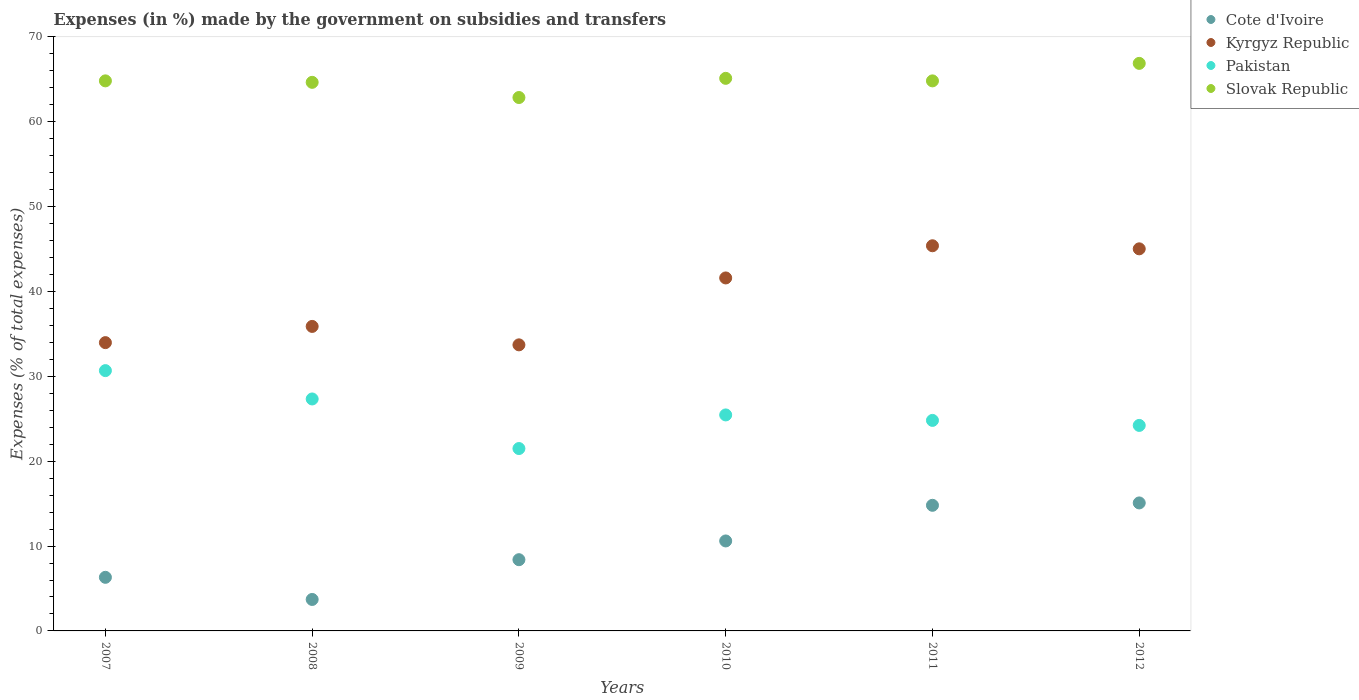Is the number of dotlines equal to the number of legend labels?
Keep it short and to the point. Yes. What is the percentage of expenses made by the government on subsidies and transfers in Cote d'Ivoire in 2008?
Provide a short and direct response. 3.71. Across all years, what is the maximum percentage of expenses made by the government on subsidies and transfers in Cote d'Ivoire?
Make the answer very short. 15.08. Across all years, what is the minimum percentage of expenses made by the government on subsidies and transfers in Pakistan?
Give a very brief answer. 21.49. In which year was the percentage of expenses made by the government on subsidies and transfers in Cote d'Ivoire minimum?
Your answer should be very brief. 2008. What is the total percentage of expenses made by the government on subsidies and transfers in Slovak Republic in the graph?
Make the answer very short. 389.15. What is the difference between the percentage of expenses made by the government on subsidies and transfers in Pakistan in 2009 and that in 2012?
Your answer should be very brief. -2.72. What is the difference between the percentage of expenses made by the government on subsidies and transfers in Slovak Republic in 2011 and the percentage of expenses made by the government on subsidies and transfers in Pakistan in 2009?
Keep it short and to the point. 43.33. What is the average percentage of expenses made by the government on subsidies and transfers in Cote d'Ivoire per year?
Offer a terse response. 9.82. In the year 2008, what is the difference between the percentage of expenses made by the government on subsidies and transfers in Cote d'Ivoire and percentage of expenses made by the government on subsidies and transfers in Slovak Republic?
Ensure brevity in your answer.  -60.94. What is the ratio of the percentage of expenses made by the government on subsidies and transfers in Slovak Republic in 2011 to that in 2012?
Keep it short and to the point. 0.97. Is the percentage of expenses made by the government on subsidies and transfers in Slovak Republic in 2007 less than that in 2009?
Your answer should be compact. No. What is the difference between the highest and the second highest percentage of expenses made by the government on subsidies and transfers in Kyrgyz Republic?
Give a very brief answer. 0.36. What is the difference between the highest and the lowest percentage of expenses made by the government on subsidies and transfers in Kyrgyz Republic?
Your answer should be very brief. 11.68. In how many years, is the percentage of expenses made by the government on subsidies and transfers in Kyrgyz Republic greater than the average percentage of expenses made by the government on subsidies and transfers in Kyrgyz Republic taken over all years?
Your response must be concise. 3. Is the percentage of expenses made by the government on subsidies and transfers in Cote d'Ivoire strictly greater than the percentage of expenses made by the government on subsidies and transfers in Kyrgyz Republic over the years?
Offer a terse response. No. Is the percentage of expenses made by the government on subsidies and transfers in Pakistan strictly less than the percentage of expenses made by the government on subsidies and transfers in Cote d'Ivoire over the years?
Ensure brevity in your answer.  No. How many dotlines are there?
Provide a short and direct response. 4. What is the difference between two consecutive major ticks on the Y-axis?
Offer a very short reply. 10. How many legend labels are there?
Provide a short and direct response. 4. What is the title of the graph?
Offer a very short reply. Expenses (in %) made by the government on subsidies and transfers. What is the label or title of the Y-axis?
Your answer should be very brief. Expenses (% of total expenses). What is the Expenses (% of total expenses) in Cote d'Ivoire in 2007?
Offer a terse response. 6.32. What is the Expenses (% of total expenses) in Kyrgyz Republic in 2007?
Provide a succinct answer. 33.97. What is the Expenses (% of total expenses) of Pakistan in 2007?
Provide a short and direct response. 30.67. What is the Expenses (% of total expenses) of Slovak Republic in 2007?
Offer a very short reply. 64.82. What is the Expenses (% of total expenses) in Cote d'Ivoire in 2008?
Ensure brevity in your answer.  3.71. What is the Expenses (% of total expenses) of Kyrgyz Republic in 2008?
Your response must be concise. 35.88. What is the Expenses (% of total expenses) in Pakistan in 2008?
Make the answer very short. 27.33. What is the Expenses (% of total expenses) in Slovak Republic in 2008?
Your answer should be very brief. 64.65. What is the Expenses (% of total expenses) of Cote d'Ivoire in 2009?
Offer a very short reply. 8.39. What is the Expenses (% of total expenses) in Kyrgyz Republic in 2009?
Keep it short and to the point. 33.71. What is the Expenses (% of total expenses) of Pakistan in 2009?
Give a very brief answer. 21.49. What is the Expenses (% of total expenses) of Slovak Republic in 2009?
Provide a short and direct response. 62.86. What is the Expenses (% of total expenses) of Cote d'Ivoire in 2010?
Keep it short and to the point. 10.6. What is the Expenses (% of total expenses) in Kyrgyz Republic in 2010?
Give a very brief answer. 41.6. What is the Expenses (% of total expenses) of Pakistan in 2010?
Offer a very short reply. 25.45. What is the Expenses (% of total expenses) of Slovak Republic in 2010?
Provide a succinct answer. 65.12. What is the Expenses (% of total expenses) of Cote d'Ivoire in 2011?
Ensure brevity in your answer.  14.8. What is the Expenses (% of total expenses) of Kyrgyz Republic in 2011?
Your response must be concise. 45.39. What is the Expenses (% of total expenses) of Pakistan in 2011?
Make the answer very short. 24.81. What is the Expenses (% of total expenses) in Slovak Republic in 2011?
Ensure brevity in your answer.  64.82. What is the Expenses (% of total expenses) of Cote d'Ivoire in 2012?
Make the answer very short. 15.08. What is the Expenses (% of total expenses) in Kyrgyz Republic in 2012?
Offer a very short reply. 45.03. What is the Expenses (% of total expenses) of Pakistan in 2012?
Your answer should be very brief. 24.22. What is the Expenses (% of total expenses) in Slovak Republic in 2012?
Ensure brevity in your answer.  66.88. Across all years, what is the maximum Expenses (% of total expenses) of Cote d'Ivoire?
Your answer should be compact. 15.08. Across all years, what is the maximum Expenses (% of total expenses) in Kyrgyz Republic?
Make the answer very short. 45.39. Across all years, what is the maximum Expenses (% of total expenses) in Pakistan?
Your response must be concise. 30.67. Across all years, what is the maximum Expenses (% of total expenses) in Slovak Republic?
Provide a short and direct response. 66.88. Across all years, what is the minimum Expenses (% of total expenses) in Cote d'Ivoire?
Offer a very short reply. 3.71. Across all years, what is the minimum Expenses (% of total expenses) of Kyrgyz Republic?
Give a very brief answer. 33.71. Across all years, what is the minimum Expenses (% of total expenses) of Pakistan?
Give a very brief answer. 21.49. Across all years, what is the minimum Expenses (% of total expenses) of Slovak Republic?
Offer a very short reply. 62.86. What is the total Expenses (% of total expenses) of Cote d'Ivoire in the graph?
Give a very brief answer. 58.91. What is the total Expenses (% of total expenses) of Kyrgyz Republic in the graph?
Your response must be concise. 235.58. What is the total Expenses (% of total expenses) in Pakistan in the graph?
Offer a very short reply. 153.98. What is the total Expenses (% of total expenses) of Slovak Republic in the graph?
Your response must be concise. 389.15. What is the difference between the Expenses (% of total expenses) in Cote d'Ivoire in 2007 and that in 2008?
Your response must be concise. 2.61. What is the difference between the Expenses (% of total expenses) in Kyrgyz Republic in 2007 and that in 2008?
Your response must be concise. -1.91. What is the difference between the Expenses (% of total expenses) in Pakistan in 2007 and that in 2008?
Your response must be concise. 3.34. What is the difference between the Expenses (% of total expenses) in Slovak Republic in 2007 and that in 2008?
Make the answer very short. 0.17. What is the difference between the Expenses (% of total expenses) of Cote d'Ivoire in 2007 and that in 2009?
Your response must be concise. -2.08. What is the difference between the Expenses (% of total expenses) in Kyrgyz Republic in 2007 and that in 2009?
Your answer should be compact. 0.26. What is the difference between the Expenses (% of total expenses) in Pakistan in 2007 and that in 2009?
Ensure brevity in your answer.  9.18. What is the difference between the Expenses (% of total expenses) of Slovak Republic in 2007 and that in 2009?
Your answer should be very brief. 1.96. What is the difference between the Expenses (% of total expenses) in Cote d'Ivoire in 2007 and that in 2010?
Your answer should be very brief. -4.29. What is the difference between the Expenses (% of total expenses) of Kyrgyz Republic in 2007 and that in 2010?
Make the answer very short. -7.62. What is the difference between the Expenses (% of total expenses) in Pakistan in 2007 and that in 2010?
Give a very brief answer. 5.22. What is the difference between the Expenses (% of total expenses) in Slovak Republic in 2007 and that in 2010?
Offer a terse response. -0.3. What is the difference between the Expenses (% of total expenses) in Cote d'Ivoire in 2007 and that in 2011?
Give a very brief answer. -8.49. What is the difference between the Expenses (% of total expenses) of Kyrgyz Republic in 2007 and that in 2011?
Your answer should be very brief. -11.41. What is the difference between the Expenses (% of total expenses) of Pakistan in 2007 and that in 2011?
Give a very brief answer. 5.87. What is the difference between the Expenses (% of total expenses) in Slovak Republic in 2007 and that in 2011?
Your answer should be compact. 0. What is the difference between the Expenses (% of total expenses) of Cote d'Ivoire in 2007 and that in 2012?
Make the answer very short. -8.77. What is the difference between the Expenses (% of total expenses) of Kyrgyz Republic in 2007 and that in 2012?
Offer a very short reply. -11.05. What is the difference between the Expenses (% of total expenses) in Pakistan in 2007 and that in 2012?
Offer a terse response. 6.46. What is the difference between the Expenses (% of total expenses) of Slovak Republic in 2007 and that in 2012?
Offer a very short reply. -2.06. What is the difference between the Expenses (% of total expenses) in Cote d'Ivoire in 2008 and that in 2009?
Ensure brevity in your answer.  -4.69. What is the difference between the Expenses (% of total expenses) in Kyrgyz Republic in 2008 and that in 2009?
Keep it short and to the point. 2.17. What is the difference between the Expenses (% of total expenses) of Pakistan in 2008 and that in 2009?
Keep it short and to the point. 5.84. What is the difference between the Expenses (% of total expenses) of Slovak Republic in 2008 and that in 2009?
Your answer should be very brief. 1.79. What is the difference between the Expenses (% of total expenses) in Cote d'Ivoire in 2008 and that in 2010?
Your response must be concise. -6.89. What is the difference between the Expenses (% of total expenses) in Kyrgyz Republic in 2008 and that in 2010?
Ensure brevity in your answer.  -5.71. What is the difference between the Expenses (% of total expenses) in Pakistan in 2008 and that in 2010?
Provide a succinct answer. 1.88. What is the difference between the Expenses (% of total expenses) of Slovak Republic in 2008 and that in 2010?
Your answer should be very brief. -0.47. What is the difference between the Expenses (% of total expenses) in Cote d'Ivoire in 2008 and that in 2011?
Make the answer very short. -11.1. What is the difference between the Expenses (% of total expenses) in Kyrgyz Republic in 2008 and that in 2011?
Your answer should be compact. -9.5. What is the difference between the Expenses (% of total expenses) of Pakistan in 2008 and that in 2011?
Your answer should be compact. 2.53. What is the difference between the Expenses (% of total expenses) in Slovak Republic in 2008 and that in 2011?
Your answer should be very brief. -0.17. What is the difference between the Expenses (% of total expenses) of Cote d'Ivoire in 2008 and that in 2012?
Provide a short and direct response. -11.38. What is the difference between the Expenses (% of total expenses) of Kyrgyz Republic in 2008 and that in 2012?
Provide a succinct answer. -9.14. What is the difference between the Expenses (% of total expenses) in Pakistan in 2008 and that in 2012?
Provide a short and direct response. 3.12. What is the difference between the Expenses (% of total expenses) of Slovak Republic in 2008 and that in 2012?
Offer a very short reply. -2.23. What is the difference between the Expenses (% of total expenses) in Cote d'Ivoire in 2009 and that in 2010?
Ensure brevity in your answer.  -2.21. What is the difference between the Expenses (% of total expenses) in Kyrgyz Republic in 2009 and that in 2010?
Provide a succinct answer. -7.88. What is the difference between the Expenses (% of total expenses) in Pakistan in 2009 and that in 2010?
Provide a succinct answer. -3.96. What is the difference between the Expenses (% of total expenses) of Slovak Republic in 2009 and that in 2010?
Keep it short and to the point. -2.26. What is the difference between the Expenses (% of total expenses) in Cote d'Ivoire in 2009 and that in 2011?
Your answer should be very brief. -6.41. What is the difference between the Expenses (% of total expenses) in Kyrgyz Republic in 2009 and that in 2011?
Offer a terse response. -11.68. What is the difference between the Expenses (% of total expenses) in Pakistan in 2009 and that in 2011?
Keep it short and to the point. -3.32. What is the difference between the Expenses (% of total expenses) of Slovak Republic in 2009 and that in 2011?
Keep it short and to the point. -1.96. What is the difference between the Expenses (% of total expenses) of Cote d'Ivoire in 2009 and that in 2012?
Your response must be concise. -6.69. What is the difference between the Expenses (% of total expenses) in Kyrgyz Republic in 2009 and that in 2012?
Provide a succinct answer. -11.32. What is the difference between the Expenses (% of total expenses) in Pakistan in 2009 and that in 2012?
Your answer should be compact. -2.72. What is the difference between the Expenses (% of total expenses) in Slovak Republic in 2009 and that in 2012?
Keep it short and to the point. -4.02. What is the difference between the Expenses (% of total expenses) in Cote d'Ivoire in 2010 and that in 2011?
Give a very brief answer. -4.2. What is the difference between the Expenses (% of total expenses) in Kyrgyz Republic in 2010 and that in 2011?
Ensure brevity in your answer.  -3.79. What is the difference between the Expenses (% of total expenses) in Pakistan in 2010 and that in 2011?
Your answer should be compact. 0.64. What is the difference between the Expenses (% of total expenses) of Slovak Republic in 2010 and that in 2011?
Give a very brief answer. 0.3. What is the difference between the Expenses (% of total expenses) of Cote d'Ivoire in 2010 and that in 2012?
Provide a succinct answer. -4.48. What is the difference between the Expenses (% of total expenses) of Kyrgyz Republic in 2010 and that in 2012?
Ensure brevity in your answer.  -3.43. What is the difference between the Expenses (% of total expenses) of Pakistan in 2010 and that in 2012?
Ensure brevity in your answer.  1.24. What is the difference between the Expenses (% of total expenses) of Slovak Republic in 2010 and that in 2012?
Provide a succinct answer. -1.76. What is the difference between the Expenses (% of total expenses) in Cote d'Ivoire in 2011 and that in 2012?
Give a very brief answer. -0.28. What is the difference between the Expenses (% of total expenses) of Kyrgyz Republic in 2011 and that in 2012?
Offer a terse response. 0.36. What is the difference between the Expenses (% of total expenses) of Pakistan in 2011 and that in 2012?
Offer a terse response. 0.59. What is the difference between the Expenses (% of total expenses) of Slovak Republic in 2011 and that in 2012?
Keep it short and to the point. -2.06. What is the difference between the Expenses (% of total expenses) in Cote d'Ivoire in 2007 and the Expenses (% of total expenses) in Kyrgyz Republic in 2008?
Your answer should be very brief. -29.57. What is the difference between the Expenses (% of total expenses) in Cote d'Ivoire in 2007 and the Expenses (% of total expenses) in Pakistan in 2008?
Offer a very short reply. -21.02. What is the difference between the Expenses (% of total expenses) of Cote d'Ivoire in 2007 and the Expenses (% of total expenses) of Slovak Republic in 2008?
Your answer should be very brief. -58.33. What is the difference between the Expenses (% of total expenses) of Kyrgyz Republic in 2007 and the Expenses (% of total expenses) of Pakistan in 2008?
Offer a terse response. 6.64. What is the difference between the Expenses (% of total expenses) in Kyrgyz Republic in 2007 and the Expenses (% of total expenses) in Slovak Republic in 2008?
Offer a terse response. -30.67. What is the difference between the Expenses (% of total expenses) in Pakistan in 2007 and the Expenses (% of total expenses) in Slovak Republic in 2008?
Keep it short and to the point. -33.97. What is the difference between the Expenses (% of total expenses) of Cote d'Ivoire in 2007 and the Expenses (% of total expenses) of Kyrgyz Republic in 2009?
Your answer should be compact. -27.4. What is the difference between the Expenses (% of total expenses) of Cote d'Ivoire in 2007 and the Expenses (% of total expenses) of Pakistan in 2009?
Make the answer very short. -15.18. What is the difference between the Expenses (% of total expenses) of Cote d'Ivoire in 2007 and the Expenses (% of total expenses) of Slovak Republic in 2009?
Your response must be concise. -56.54. What is the difference between the Expenses (% of total expenses) in Kyrgyz Republic in 2007 and the Expenses (% of total expenses) in Pakistan in 2009?
Your answer should be compact. 12.48. What is the difference between the Expenses (% of total expenses) in Kyrgyz Republic in 2007 and the Expenses (% of total expenses) in Slovak Republic in 2009?
Provide a short and direct response. -28.88. What is the difference between the Expenses (% of total expenses) of Pakistan in 2007 and the Expenses (% of total expenses) of Slovak Republic in 2009?
Your answer should be compact. -32.18. What is the difference between the Expenses (% of total expenses) in Cote d'Ivoire in 2007 and the Expenses (% of total expenses) in Kyrgyz Republic in 2010?
Your answer should be very brief. -35.28. What is the difference between the Expenses (% of total expenses) of Cote d'Ivoire in 2007 and the Expenses (% of total expenses) of Pakistan in 2010?
Ensure brevity in your answer.  -19.14. What is the difference between the Expenses (% of total expenses) of Cote d'Ivoire in 2007 and the Expenses (% of total expenses) of Slovak Republic in 2010?
Provide a short and direct response. -58.8. What is the difference between the Expenses (% of total expenses) in Kyrgyz Republic in 2007 and the Expenses (% of total expenses) in Pakistan in 2010?
Your answer should be very brief. 8.52. What is the difference between the Expenses (% of total expenses) of Kyrgyz Republic in 2007 and the Expenses (% of total expenses) of Slovak Republic in 2010?
Keep it short and to the point. -31.14. What is the difference between the Expenses (% of total expenses) in Pakistan in 2007 and the Expenses (% of total expenses) in Slovak Republic in 2010?
Your response must be concise. -34.44. What is the difference between the Expenses (% of total expenses) in Cote d'Ivoire in 2007 and the Expenses (% of total expenses) in Kyrgyz Republic in 2011?
Your answer should be compact. -39.07. What is the difference between the Expenses (% of total expenses) of Cote d'Ivoire in 2007 and the Expenses (% of total expenses) of Pakistan in 2011?
Offer a terse response. -18.49. What is the difference between the Expenses (% of total expenses) of Cote d'Ivoire in 2007 and the Expenses (% of total expenses) of Slovak Republic in 2011?
Offer a terse response. -58.5. What is the difference between the Expenses (% of total expenses) of Kyrgyz Republic in 2007 and the Expenses (% of total expenses) of Pakistan in 2011?
Your answer should be very brief. 9.16. What is the difference between the Expenses (% of total expenses) in Kyrgyz Republic in 2007 and the Expenses (% of total expenses) in Slovak Republic in 2011?
Provide a succinct answer. -30.85. What is the difference between the Expenses (% of total expenses) of Pakistan in 2007 and the Expenses (% of total expenses) of Slovak Republic in 2011?
Offer a very short reply. -34.15. What is the difference between the Expenses (% of total expenses) in Cote d'Ivoire in 2007 and the Expenses (% of total expenses) in Kyrgyz Republic in 2012?
Make the answer very short. -38.71. What is the difference between the Expenses (% of total expenses) in Cote d'Ivoire in 2007 and the Expenses (% of total expenses) in Pakistan in 2012?
Offer a very short reply. -17.9. What is the difference between the Expenses (% of total expenses) in Cote d'Ivoire in 2007 and the Expenses (% of total expenses) in Slovak Republic in 2012?
Provide a succinct answer. -60.57. What is the difference between the Expenses (% of total expenses) in Kyrgyz Republic in 2007 and the Expenses (% of total expenses) in Pakistan in 2012?
Your response must be concise. 9.76. What is the difference between the Expenses (% of total expenses) of Kyrgyz Republic in 2007 and the Expenses (% of total expenses) of Slovak Republic in 2012?
Ensure brevity in your answer.  -32.91. What is the difference between the Expenses (% of total expenses) of Pakistan in 2007 and the Expenses (% of total expenses) of Slovak Republic in 2012?
Provide a short and direct response. -36.21. What is the difference between the Expenses (% of total expenses) in Cote d'Ivoire in 2008 and the Expenses (% of total expenses) in Kyrgyz Republic in 2009?
Your response must be concise. -30. What is the difference between the Expenses (% of total expenses) of Cote d'Ivoire in 2008 and the Expenses (% of total expenses) of Pakistan in 2009?
Offer a very short reply. -17.79. What is the difference between the Expenses (% of total expenses) of Cote d'Ivoire in 2008 and the Expenses (% of total expenses) of Slovak Republic in 2009?
Ensure brevity in your answer.  -59.15. What is the difference between the Expenses (% of total expenses) in Kyrgyz Republic in 2008 and the Expenses (% of total expenses) in Pakistan in 2009?
Provide a short and direct response. 14.39. What is the difference between the Expenses (% of total expenses) of Kyrgyz Republic in 2008 and the Expenses (% of total expenses) of Slovak Republic in 2009?
Ensure brevity in your answer.  -26.97. What is the difference between the Expenses (% of total expenses) in Pakistan in 2008 and the Expenses (% of total expenses) in Slovak Republic in 2009?
Make the answer very short. -35.52. What is the difference between the Expenses (% of total expenses) of Cote d'Ivoire in 2008 and the Expenses (% of total expenses) of Kyrgyz Republic in 2010?
Your answer should be compact. -37.89. What is the difference between the Expenses (% of total expenses) of Cote d'Ivoire in 2008 and the Expenses (% of total expenses) of Pakistan in 2010?
Your response must be concise. -21.75. What is the difference between the Expenses (% of total expenses) of Cote d'Ivoire in 2008 and the Expenses (% of total expenses) of Slovak Republic in 2010?
Ensure brevity in your answer.  -61.41. What is the difference between the Expenses (% of total expenses) in Kyrgyz Republic in 2008 and the Expenses (% of total expenses) in Pakistan in 2010?
Your answer should be compact. 10.43. What is the difference between the Expenses (% of total expenses) of Kyrgyz Republic in 2008 and the Expenses (% of total expenses) of Slovak Republic in 2010?
Offer a very short reply. -29.23. What is the difference between the Expenses (% of total expenses) in Pakistan in 2008 and the Expenses (% of total expenses) in Slovak Republic in 2010?
Provide a succinct answer. -37.78. What is the difference between the Expenses (% of total expenses) in Cote d'Ivoire in 2008 and the Expenses (% of total expenses) in Kyrgyz Republic in 2011?
Provide a short and direct response. -41.68. What is the difference between the Expenses (% of total expenses) in Cote d'Ivoire in 2008 and the Expenses (% of total expenses) in Pakistan in 2011?
Make the answer very short. -21.1. What is the difference between the Expenses (% of total expenses) of Cote d'Ivoire in 2008 and the Expenses (% of total expenses) of Slovak Republic in 2011?
Offer a terse response. -61.11. What is the difference between the Expenses (% of total expenses) in Kyrgyz Republic in 2008 and the Expenses (% of total expenses) in Pakistan in 2011?
Give a very brief answer. 11.07. What is the difference between the Expenses (% of total expenses) of Kyrgyz Republic in 2008 and the Expenses (% of total expenses) of Slovak Republic in 2011?
Provide a short and direct response. -28.94. What is the difference between the Expenses (% of total expenses) in Pakistan in 2008 and the Expenses (% of total expenses) in Slovak Republic in 2011?
Ensure brevity in your answer.  -37.48. What is the difference between the Expenses (% of total expenses) in Cote d'Ivoire in 2008 and the Expenses (% of total expenses) in Kyrgyz Republic in 2012?
Provide a succinct answer. -41.32. What is the difference between the Expenses (% of total expenses) in Cote d'Ivoire in 2008 and the Expenses (% of total expenses) in Pakistan in 2012?
Offer a terse response. -20.51. What is the difference between the Expenses (% of total expenses) in Cote d'Ivoire in 2008 and the Expenses (% of total expenses) in Slovak Republic in 2012?
Provide a short and direct response. -63.17. What is the difference between the Expenses (% of total expenses) of Kyrgyz Republic in 2008 and the Expenses (% of total expenses) of Pakistan in 2012?
Keep it short and to the point. 11.67. What is the difference between the Expenses (% of total expenses) of Kyrgyz Republic in 2008 and the Expenses (% of total expenses) of Slovak Republic in 2012?
Ensure brevity in your answer.  -31. What is the difference between the Expenses (% of total expenses) of Pakistan in 2008 and the Expenses (% of total expenses) of Slovak Republic in 2012?
Keep it short and to the point. -39.55. What is the difference between the Expenses (% of total expenses) of Cote d'Ivoire in 2009 and the Expenses (% of total expenses) of Kyrgyz Republic in 2010?
Keep it short and to the point. -33.2. What is the difference between the Expenses (% of total expenses) in Cote d'Ivoire in 2009 and the Expenses (% of total expenses) in Pakistan in 2010?
Your answer should be very brief. -17.06. What is the difference between the Expenses (% of total expenses) of Cote d'Ivoire in 2009 and the Expenses (% of total expenses) of Slovak Republic in 2010?
Keep it short and to the point. -56.72. What is the difference between the Expenses (% of total expenses) of Kyrgyz Republic in 2009 and the Expenses (% of total expenses) of Pakistan in 2010?
Provide a succinct answer. 8.26. What is the difference between the Expenses (% of total expenses) of Kyrgyz Republic in 2009 and the Expenses (% of total expenses) of Slovak Republic in 2010?
Provide a succinct answer. -31.41. What is the difference between the Expenses (% of total expenses) in Pakistan in 2009 and the Expenses (% of total expenses) in Slovak Republic in 2010?
Your response must be concise. -43.63. What is the difference between the Expenses (% of total expenses) in Cote d'Ivoire in 2009 and the Expenses (% of total expenses) in Kyrgyz Republic in 2011?
Give a very brief answer. -36.99. What is the difference between the Expenses (% of total expenses) of Cote d'Ivoire in 2009 and the Expenses (% of total expenses) of Pakistan in 2011?
Keep it short and to the point. -16.42. What is the difference between the Expenses (% of total expenses) of Cote d'Ivoire in 2009 and the Expenses (% of total expenses) of Slovak Republic in 2011?
Your answer should be very brief. -56.43. What is the difference between the Expenses (% of total expenses) in Kyrgyz Republic in 2009 and the Expenses (% of total expenses) in Pakistan in 2011?
Provide a short and direct response. 8.9. What is the difference between the Expenses (% of total expenses) in Kyrgyz Republic in 2009 and the Expenses (% of total expenses) in Slovak Republic in 2011?
Make the answer very short. -31.11. What is the difference between the Expenses (% of total expenses) of Pakistan in 2009 and the Expenses (% of total expenses) of Slovak Republic in 2011?
Your answer should be compact. -43.33. What is the difference between the Expenses (% of total expenses) of Cote d'Ivoire in 2009 and the Expenses (% of total expenses) of Kyrgyz Republic in 2012?
Keep it short and to the point. -36.63. What is the difference between the Expenses (% of total expenses) of Cote d'Ivoire in 2009 and the Expenses (% of total expenses) of Pakistan in 2012?
Offer a terse response. -15.82. What is the difference between the Expenses (% of total expenses) in Cote d'Ivoire in 2009 and the Expenses (% of total expenses) in Slovak Republic in 2012?
Keep it short and to the point. -58.49. What is the difference between the Expenses (% of total expenses) of Kyrgyz Republic in 2009 and the Expenses (% of total expenses) of Pakistan in 2012?
Offer a very short reply. 9.49. What is the difference between the Expenses (% of total expenses) in Kyrgyz Republic in 2009 and the Expenses (% of total expenses) in Slovak Republic in 2012?
Your response must be concise. -33.17. What is the difference between the Expenses (% of total expenses) of Pakistan in 2009 and the Expenses (% of total expenses) of Slovak Republic in 2012?
Your answer should be very brief. -45.39. What is the difference between the Expenses (% of total expenses) in Cote d'Ivoire in 2010 and the Expenses (% of total expenses) in Kyrgyz Republic in 2011?
Provide a succinct answer. -34.79. What is the difference between the Expenses (% of total expenses) in Cote d'Ivoire in 2010 and the Expenses (% of total expenses) in Pakistan in 2011?
Your response must be concise. -14.21. What is the difference between the Expenses (% of total expenses) of Cote d'Ivoire in 2010 and the Expenses (% of total expenses) of Slovak Republic in 2011?
Provide a short and direct response. -54.22. What is the difference between the Expenses (% of total expenses) of Kyrgyz Republic in 2010 and the Expenses (% of total expenses) of Pakistan in 2011?
Your answer should be compact. 16.79. What is the difference between the Expenses (% of total expenses) of Kyrgyz Republic in 2010 and the Expenses (% of total expenses) of Slovak Republic in 2011?
Provide a short and direct response. -23.22. What is the difference between the Expenses (% of total expenses) of Pakistan in 2010 and the Expenses (% of total expenses) of Slovak Republic in 2011?
Keep it short and to the point. -39.37. What is the difference between the Expenses (% of total expenses) of Cote d'Ivoire in 2010 and the Expenses (% of total expenses) of Kyrgyz Republic in 2012?
Make the answer very short. -34.42. What is the difference between the Expenses (% of total expenses) of Cote d'Ivoire in 2010 and the Expenses (% of total expenses) of Pakistan in 2012?
Ensure brevity in your answer.  -13.61. What is the difference between the Expenses (% of total expenses) of Cote d'Ivoire in 2010 and the Expenses (% of total expenses) of Slovak Republic in 2012?
Provide a short and direct response. -56.28. What is the difference between the Expenses (% of total expenses) in Kyrgyz Republic in 2010 and the Expenses (% of total expenses) in Pakistan in 2012?
Keep it short and to the point. 17.38. What is the difference between the Expenses (% of total expenses) in Kyrgyz Republic in 2010 and the Expenses (% of total expenses) in Slovak Republic in 2012?
Keep it short and to the point. -25.29. What is the difference between the Expenses (% of total expenses) in Pakistan in 2010 and the Expenses (% of total expenses) in Slovak Republic in 2012?
Provide a short and direct response. -41.43. What is the difference between the Expenses (% of total expenses) in Cote d'Ivoire in 2011 and the Expenses (% of total expenses) in Kyrgyz Republic in 2012?
Offer a terse response. -30.22. What is the difference between the Expenses (% of total expenses) in Cote d'Ivoire in 2011 and the Expenses (% of total expenses) in Pakistan in 2012?
Make the answer very short. -9.41. What is the difference between the Expenses (% of total expenses) in Cote d'Ivoire in 2011 and the Expenses (% of total expenses) in Slovak Republic in 2012?
Provide a short and direct response. -52.08. What is the difference between the Expenses (% of total expenses) of Kyrgyz Republic in 2011 and the Expenses (% of total expenses) of Pakistan in 2012?
Your response must be concise. 21.17. What is the difference between the Expenses (% of total expenses) in Kyrgyz Republic in 2011 and the Expenses (% of total expenses) in Slovak Republic in 2012?
Give a very brief answer. -21.49. What is the difference between the Expenses (% of total expenses) of Pakistan in 2011 and the Expenses (% of total expenses) of Slovak Republic in 2012?
Provide a succinct answer. -42.07. What is the average Expenses (% of total expenses) of Cote d'Ivoire per year?
Ensure brevity in your answer.  9.82. What is the average Expenses (% of total expenses) in Kyrgyz Republic per year?
Your answer should be very brief. 39.26. What is the average Expenses (% of total expenses) in Pakistan per year?
Keep it short and to the point. 25.66. What is the average Expenses (% of total expenses) in Slovak Republic per year?
Ensure brevity in your answer.  64.86. In the year 2007, what is the difference between the Expenses (% of total expenses) of Cote d'Ivoire and Expenses (% of total expenses) of Kyrgyz Republic?
Provide a succinct answer. -27.66. In the year 2007, what is the difference between the Expenses (% of total expenses) in Cote d'Ivoire and Expenses (% of total expenses) in Pakistan?
Provide a succinct answer. -24.36. In the year 2007, what is the difference between the Expenses (% of total expenses) in Cote d'Ivoire and Expenses (% of total expenses) in Slovak Republic?
Provide a short and direct response. -58.51. In the year 2007, what is the difference between the Expenses (% of total expenses) of Kyrgyz Republic and Expenses (% of total expenses) of Pakistan?
Offer a very short reply. 3.3. In the year 2007, what is the difference between the Expenses (% of total expenses) of Kyrgyz Republic and Expenses (% of total expenses) of Slovak Republic?
Provide a succinct answer. -30.85. In the year 2007, what is the difference between the Expenses (% of total expenses) of Pakistan and Expenses (% of total expenses) of Slovak Republic?
Your response must be concise. -34.15. In the year 2008, what is the difference between the Expenses (% of total expenses) of Cote d'Ivoire and Expenses (% of total expenses) of Kyrgyz Republic?
Offer a very short reply. -32.18. In the year 2008, what is the difference between the Expenses (% of total expenses) of Cote d'Ivoire and Expenses (% of total expenses) of Pakistan?
Offer a very short reply. -23.63. In the year 2008, what is the difference between the Expenses (% of total expenses) of Cote d'Ivoire and Expenses (% of total expenses) of Slovak Republic?
Offer a terse response. -60.94. In the year 2008, what is the difference between the Expenses (% of total expenses) of Kyrgyz Republic and Expenses (% of total expenses) of Pakistan?
Your response must be concise. 8.55. In the year 2008, what is the difference between the Expenses (% of total expenses) in Kyrgyz Republic and Expenses (% of total expenses) in Slovak Republic?
Your answer should be compact. -28.76. In the year 2008, what is the difference between the Expenses (% of total expenses) in Pakistan and Expenses (% of total expenses) in Slovak Republic?
Offer a terse response. -37.31. In the year 2009, what is the difference between the Expenses (% of total expenses) of Cote d'Ivoire and Expenses (% of total expenses) of Kyrgyz Republic?
Offer a very short reply. -25.32. In the year 2009, what is the difference between the Expenses (% of total expenses) in Cote d'Ivoire and Expenses (% of total expenses) in Pakistan?
Provide a succinct answer. -13.1. In the year 2009, what is the difference between the Expenses (% of total expenses) in Cote d'Ivoire and Expenses (% of total expenses) in Slovak Republic?
Provide a succinct answer. -54.46. In the year 2009, what is the difference between the Expenses (% of total expenses) in Kyrgyz Republic and Expenses (% of total expenses) in Pakistan?
Your answer should be very brief. 12.22. In the year 2009, what is the difference between the Expenses (% of total expenses) of Kyrgyz Republic and Expenses (% of total expenses) of Slovak Republic?
Ensure brevity in your answer.  -29.15. In the year 2009, what is the difference between the Expenses (% of total expenses) of Pakistan and Expenses (% of total expenses) of Slovak Republic?
Offer a terse response. -41.36. In the year 2010, what is the difference between the Expenses (% of total expenses) in Cote d'Ivoire and Expenses (% of total expenses) in Kyrgyz Republic?
Offer a very short reply. -30.99. In the year 2010, what is the difference between the Expenses (% of total expenses) of Cote d'Ivoire and Expenses (% of total expenses) of Pakistan?
Offer a very short reply. -14.85. In the year 2010, what is the difference between the Expenses (% of total expenses) of Cote d'Ivoire and Expenses (% of total expenses) of Slovak Republic?
Your answer should be compact. -54.52. In the year 2010, what is the difference between the Expenses (% of total expenses) in Kyrgyz Republic and Expenses (% of total expenses) in Pakistan?
Your response must be concise. 16.14. In the year 2010, what is the difference between the Expenses (% of total expenses) in Kyrgyz Republic and Expenses (% of total expenses) in Slovak Republic?
Your answer should be very brief. -23.52. In the year 2010, what is the difference between the Expenses (% of total expenses) in Pakistan and Expenses (% of total expenses) in Slovak Republic?
Ensure brevity in your answer.  -39.66. In the year 2011, what is the difference between the Expenses (% of total expenses) in Cote d'Ivoire and Expenses (% of total expenses) in Kyrgyz Republic?
Ensure brevity in your answer.  -30.59. In the year 2011, what is the difference between the Expenses (% of total expenses) of Cote d'Ivoire and Expenses (% of total expenses) of Pakistan?
Offer a terse response. -10.01. In the year 2011, what is the difference between the Expenses (% of total expenses) in Cote d'Ivoire and Expenses (% of total expenses) in Slovak Republic?
Ensure brevity in your answer.  -50.02. In the year 2011, what is the difference between the Expenses (% of total expenses) in Kyrgyz Republic and Expenses (% of total expenses) in Pakistan?
Your answer should be very brief. 20.58. In the year 2011, what is the difference between the Expenses (% of total expenses) of Kyrgyz Republic and Expenses (% of total expenses) of Slovak Republic?
Give a very brief answer. -19.43. In the year 2011, what is the difference between the Expenses (% of total expenses) in Pakistan and Expenses (% of total expenses) in Slovak Republic?
Provide a succinct answer. -40.01. In the year 2012, what is the difference between the Expenses (% of total expenses) of Cote d'Ivoire and Expenses (% of total expenses) of Kyrgyz Republic?
Your response must be concise. -29.94. In the year 2012, what is the difference between the Expenses (% of total expenses) in Cote d'Ivoire and Expenses (% of total expenses) in Pakistan?
Give a very brief answer. -9.13. In the year 2012, what is the difference between the Expenses (% of total expenses) of Cote d'Ivoire and Expenses (% of total expenses) of Slovak Republic?
Your response must be concise. -51.8. In the year 2012, what is the difference between the Expenses (% of total expenses) of Kyrgyz Republic and Expenses (% of total expenses) of Pakistan?
Your response must be concise. 20.81. In the year 2012, what is the difference between the Expenses (% of total expenses) of Kyrgyz Republic and Expenses (% of total expenses) of Slovak Republic?
Your answer should be compact. -21.86. In the year 2012, what is the difference between the Expenses (% of total expenses) of Pakistan and Expenses (% of total expenses) of Slovak Republic?
Offer a very short reply. -42.66. What is the ratio of the Expenses (% of total expenses) of Cote d'Ivoire in 2007 to that in 2008?
Offer a very short reply. 1.7. What is the ratio of the Expenses (% of total expenses) in Kyrgyz Republic in 2007 to that in 2008?
Your answer should be very brief. 0.95. What is the ratio of the Expenses (% of total expenses) of Pakistan in 2007 to that in 2008?
Provide a succinct answer. 1.12. What is the ratio of the Expenses (% of total expenses) of Slovak Republic in 2007 to that in 2008?
Offer a terse response. 1. What is the ratio of the Expenses (% of total expenses) of Cote d'Ivoire in 2007 to that in 2009?
Offer a very short reply. 0.75. What is the ratio of the Expenses (% of total expenses) of Kyrgyz Republic in 2007 to that in 2009?
Your answer should be very brief. 1.01. What is the ratio of the Expenses (% of total expenses) of Pakistan in 2007 to that in 2009?
Your answer should be very brief. 1.43. What is the ratio of the Expenses (% of total expenses) in Slovak Republic in 2007 to that in 2009?
Offer a very short reply. 1.03. What is the ratio of the Expenses (% of total expenses) in Cote d'Ivoire in 2007 to that in 2010?
Provide a short and direct response. 0.6. What is the ratio of the Expenses (% of total expenses) of Kyrgyz Republic in 2007 to that in 2010?
Ensure brevity in your answer.  0.82. What is the ratio of the Expenses (% of total expenses) in Pakistan in 2007 to that in 2010?
Make the answer very short. 1.21. What is the ratio of the Expenses (% of total expenses) of Slovak Republic in 2007 to that in 2010?
Your response must be concise. 1. What is the ratio of the Expenses (% of total expenses) of Cote d'Ivoire in 2007 to that in 2011?
Provide a succinct answer. 0.43. What is the ratio of the Expenses (% of total expenses) in Kyrgyz Republic in 2007 to that in 2011?
Provide a succinct answer. 0.75. What is the ratio of the Expenses (% of total expenses) of Pakistan in 2007 to that in 2011?
Offer a terse response. 1.24. What is the ratio of the Expenses (% of total expenses) in Slovak Republic in 2007 to that in 2011?
Your answer should be very brief. 1. What is the ratio of the Expenses (% of total expenses) in Cote d'Ivoire in 2007 to that in 2012?
Provide a succinct answer. 0.42. What is the ratio of the Expenses (% of total expenses) of Kyrgyz Republic in 2007 to that in 2012?
Keep it short and to the point. 0.75. What is the ratio of the Expenses (% of total expenses) of Pakistan in 2007 to that in 2012?
Keep it short and to the point. 1.27. What is the ratio of the Expenses (% of total expenses) in Slovak Republic in 2007 to that in 2012?
Provide a short and direct response. 0.97. What is the ratio of the Expenses (% of total expenses) of Cote d'Ivoire in 2008 to that in 2009?
Your response must be concise. 0.44. What is the ratio of the Expenses (% of total expenses) in Kyrgyz Republic in 2008 to that in 2009?
Provide a short and direct response. 1.06. What is the ratio of the Expenses (% of total expenses) of Pakistan in 2008 to that in 2009?
Keep it short and to the point. 1.27. What is the ratio of the Expenses (% of total expenses) in Slovak Republic in 2008 to that in 2009?
Offer a terse response. 1.03. What is the ratio of the Expenses (% of total expenses) in Cote d'Ivoire in 2008 to that in 2010?
Provide a short and direct response. 0.35. What is the ratio of the Expenses (% of total expenses) of Kyrgyz Republic in 2008 to that in 2010?
Offer a terse response. 0.86. What is the ratio of the Expenses (% of total expenses) in Pakistan in 2008 to that in 2010?
Your answer should be very brief. 1.07. What is the ratio of the Expenses (% of total expenses) of Cote d'Ivoire in 2008 to that in 2011?
Give a very brief answer. 0.25. What is the ratio of the Expenses (% of total expenses) in Kyrgyz Republic in 2008 to that in 2011?
Your answer should be compact. 0.79. What is the ratio of the Expenses (% of total expenses) in Pakistan in 2008 to that in 2011?
Ensure brevity in your answer.  1.1. What is the ratio of the Expenses (% of total expenses) in Cote d'Ivoire in 2008 to that in 2012?
Make the answer very short. 0.25. What is the ratio of the Expenses (% of total expenses) in Kyrgyz Republic in 2008 to that in 2012?
Offer a very short reply. 0.8. What is the ratio of the Expenses (% of total expenses) in Pakistan in 2008 to that in 2012?
Keep it short and to the point. 1.13. What is the ratio of the Expenses (% of total expenses) of Slovak Republic in 2008 to that in 2012?
Keep it short and to the point. 0.97. What is the ratio of the Expenses (% of total expenses) in Cote d'Ivoire in 2009 to that in 2010?
Your answer should be compact. 0.79. What is the ratio of the Expenses (% of total expenses) in Kyrgyz Republic in 2009 to that in 2010?
Provide a succinct answer. 0.81. What is the ratio of the Expenses (% of total expenses) of Pakistan in 2009 to that in 2010?
Offer a terse response. 0.84. What is the ratio of the Expenses (% of total expenses) in Slovak Republic in 2009 to that in 2010?
Offer a terse response. 0.97. What is the ratio of the Expenses (% of total expenses) of Cote d'Ivoire in 2009 to that in 2011?
Your answer should be very brief. 0.57. What is the ratio of the Expenses (% of total expenses) of Kyrgyz Republic in 2009 to that in 2011?
Your answer should be very brief. 0.74. What is the ratio of the Expenses (% of total expenses) in Pakistan in 2009 to that in 2011?
Your answer should be very brief. 0.87. What is the ratio of the Expenses (% of total expenses) in Slovak Republic in 2009 to that in 2011?
Provide a succinct answer. 0.97. What is the ratio of the Expenses (% of total expenses) of Cote d'Ivoire in 2009 to that in 2012?
Provide a succinct answer. 0.56. What is the ratio of the Expenses (% of total expenses) of Kyrgyz Republic in 2009 to that in 2012?
Give a very brief answer. 0.75. What is the ratio of the Expenses (% of total expenses) of Pakistan in 2009 to that in 2012?
Provide a succinct answer. 0.89. What is the ratio of the Expenses (% of total expenses) of Slovak Republic in 2009 to that in 2012?
Give a very brief answer. 0.94. What is the ratio of the Expenses (% of total expenses) in Cote d'Ivoire in 2010 to that in 2011?
Make the answer very short. 0.72. What is the ratio of the Expenses (% of total expenses) in Kyrgyz Republic in 2010 to that in 2011?
Offer a very short reply. 0.92. What is the ratio of the Expenses (% of total expenses) in Pakistan in 2010 to that in 2011?
Offer a terse response. 1.03. What is the ratio of the Expenses (% of total expenses) of Cote d'Ivoire in 2010 to that in 2012?
Give a very brief answer. 0.7. What is the ratio of the Expenses (% of total expenses) in Kyrgyz Republic in 2010 to that in 2012?
Provide a short and direct response. 0.92. What is the ratio of the Expenses (% of total expenses) of Pakistan in 2010 to that in 2012?
Keep it short and to the point. 1.05. What is the ratio of the Expenses (% of total expenses) in Slovak Republic in 2010 to that in 2012?
Offer a very short reply. 0.97. What is the ratio of the Expenses (% of total expenses) of Cote d'Ivoire in 2011 to that in 2012?
Make the answer very short. 0.98. What is the ratio of the Expenses (% of total expenses) of Pakistan in 2011 to that in 2012?
Give a very brief answer. 1.02. What is the ratio of the Expenses (% of total expenses) of Slovak Republic in 2011 to that in 2012?
Offer a very short reply. 0.97. What is the difference between the highest and the second highest Expenses (% of total expenses) in Cote d'Ivoire?
Offer a very short reply. 0.28. What is the difference between the highest and the second highest Expenses (% of total expenses) in Kyrgyz Republic?
Your answer should be very brief. 0.36. What is the difference between the highest and the second highest Expenses (% of total expenses) in Pakistan?
Give a very brief answer. 3.34. What is the difference between the highest and the second highest Expenses (% of total expenses) of Slovak Republic?
Offer a terse response. 1.76. What is the difference between the highest and the lowest Expenses (% of total expenses) of Cote d'Ivoire?
Provide a succinct answer. 11.38. What is the difference between the highest and the lowest Expenses (% of total expenses) of Kyrgyz Republic?
Make the answer very short. 11.68. What is the difference between the highest and the lowest Expenses (% of total expenses) in Pakistan?
Your answer should be compact. 9.18. What is the difference between the highest and the lowest Expenses (% of total expenses) in Slovak Republic?
Your answer should be very brief. 4.02. 